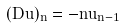Convert formula to latex. <formula><loc_0><loc_0><loc_500><loc_500>( D u ) _ { n } = - n u _ { n - 1 }</formula> 